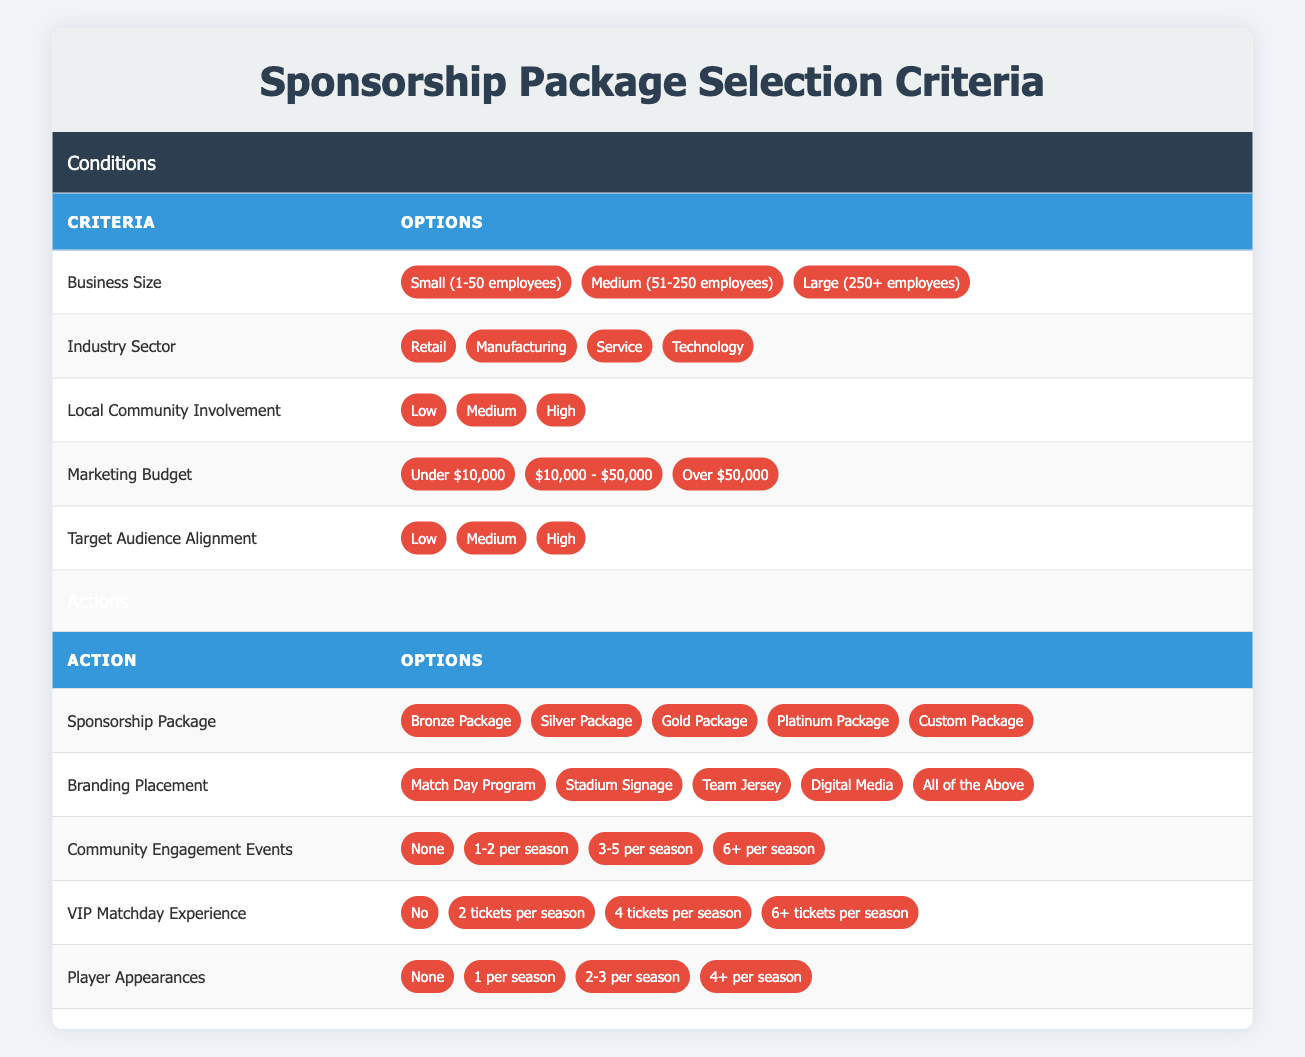What are the options for Business Size? The table lists three options for Business Size: Small (1-50 employees), Medium (51-250 employees), and Large (250+ employees).
Answer: Small, Medium, Large Which Sponsorship Package is available for businesses with a marketing budget of under $10,000? According to the table, businesses with a marketing budget of under $10,000 can choose any Sponsorship Package. However, usually, lower budgets may gravitate towards the Bronze Package.
Answer: Bronze Package Is there an option for Community Engagement Events that allows for 6 or more events per season? Yes, the table includes an option for Community Engagement Events that states "6+ per season."
Answer: Yes What is the highest number of Player Appearances offered in a Sponsorship Package? The highest number of Player Appearances listed in the table is "4+ per season."
Answer: 4+ If a business is classified as "Medium" in Local Community Involvement and has a marketing budget of over $50,000, what are the possible Sponsorship Packages available? For a business classified as "Medium" in Local Community Involvement and with a marketing budget of over $50,000, the available Sponsorship Packages are Bronze, Silver, Gold, and Platinum. This is because all packages are open to medium involvement and a higher budget.
Answer: Bronze, Silver, Gold, Platinum What could be the potential Branding Placement options for a Silver Package? In the table, the Silver Package allows for multiple branding placements, including the Match Day Program, Stadium Signage, Team Jersey, Digital Media, and All of the Above options. Therefore, a Silver Package can include any of these branding placements.
Answer: All of the Above How many options are there for Local Community Involvement, and what are they? There are three options for Local Community Involvement: Low, Medium, and High. Counting these gives us three different levels of involvement.
Answer: 3: Low, Medium, High What is the average target audience alignment among small-sized businesses? Each small-sized business might align differently, but typically, more engaged businesses may fall under "High" or "Medium" alignment. However, without specific data on their choices, an average cannot be calculated. This illustrates the need for more information about actual choices made by small businesses in the table context.
Answer: Cannot be determined In terms of VIP Matchday Experience, do all packages provide at least 2 tickets per season? No, one of the options under VIP Matchday Experience is "No," meaning that not all packages provide tickets and at least one option exists that does not offer tickets.
Answer: No 